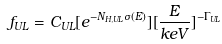Convert formula to latex. <formula><loc_0><loc_0><loc_500><loc_500>f _ { U L } = C _ { U L } [ e ^ { - N _ { H , U L } \sigma ( E ) } ] [ \frac { E } { k e V } ] ^ { - \Gamma _ { U L } }</formula> 